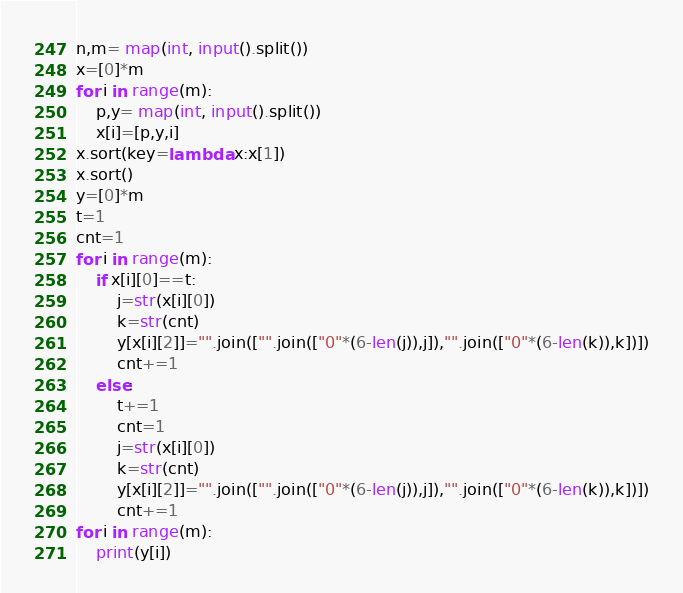<code> <loc_0><loc_0><loc_500><loc_500><_Python_>n,m= map(int, input().split())
x=[0]*m
for i in range(m):
    p,y= map(int, input().split())
    x[i]=[p,y,i]
x.sort(key=lambda x:x[1])
x.sort()
y=[0]*m
t=1
cnt=1
for i in range(m):
    if x[i][0]==t:
        j=str(x[i][0])
        k=str(cnt)
        y[x[i][2]]="".join(["".join(["0"*(6-len(j)),j]),"".join(["0"*(6-len(k)),k])])
        cnt+=1
    else:
        t+=1
        cnt=1
        j=str(x[i][0])
        k=str(cnt)
        y[x[i][2]]="".join(["".join(["0"*(6-len(j)),j]),"".join(["0"*(6-len(k)),k])])
        cnt+=1
for i in range(m):
    print(y[i])</code> 